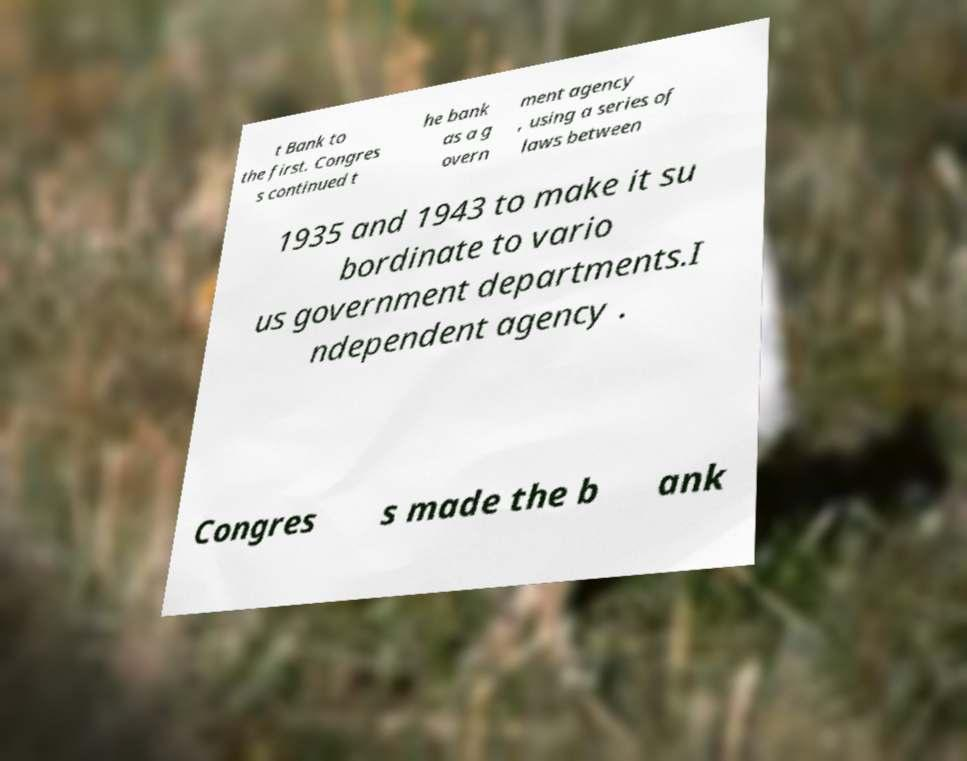Can you accurately transcribe the text from the provided image for me? t Bank to the first. Congres s continued t he bank as a g overn ment agency , using a series of laws between 1935 and 1943 to make it su bordinate to vario us government departments.I ndependent agency . Congres s made the b ank 